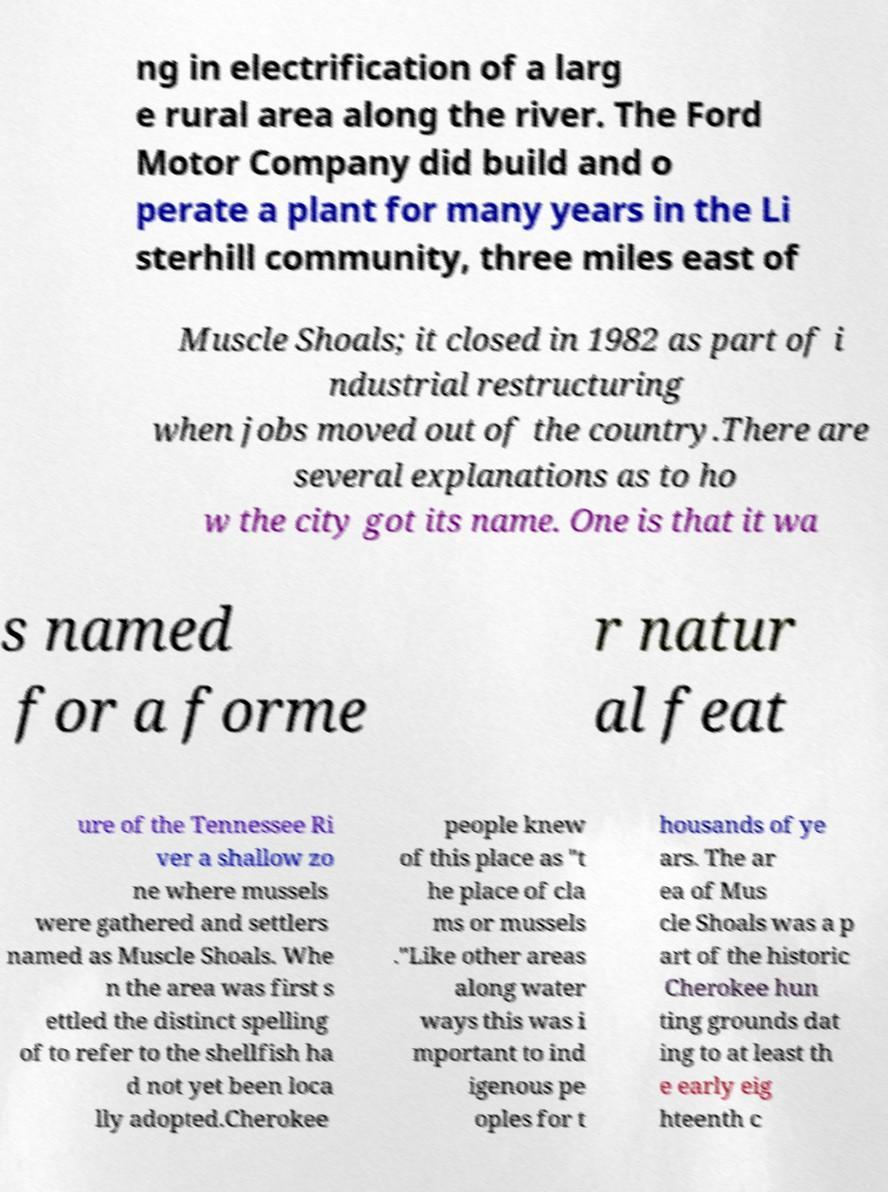There's text embedded in this image that I need extracted. Can you transcribe it verbatim? ng in electrification of a larg e rural area along the river. The Ford Motor Company did build and o perate a plant for many years in the Li sterhill community, three miles east of Muscle Shoals; it closed in 1982 as part of i ndustrial restructuring when jobs moved out of the country.There are several explanations as to ho w the city got its name. One is that it wa s named for a forme r natur al feat ure of the Tennessee Ri ver a shallow zo ne where mussels were gathered and settlers named as Muscle Shoals. Whe n the area was first s ettled the distinct spelling of to refer to the shellfish ha d not yet been loca lly adopted.Cherokee people knew of this place as "t he place of cla ms or mussels ."Like other areas along water ways this was i mportant to ind igenous pe oples for t housands of ye ars. The ar ea of Mus cle Shoals was a p art of the historic Cherokee hun ting grounds dat ing to at least th e early eig hteenth c 